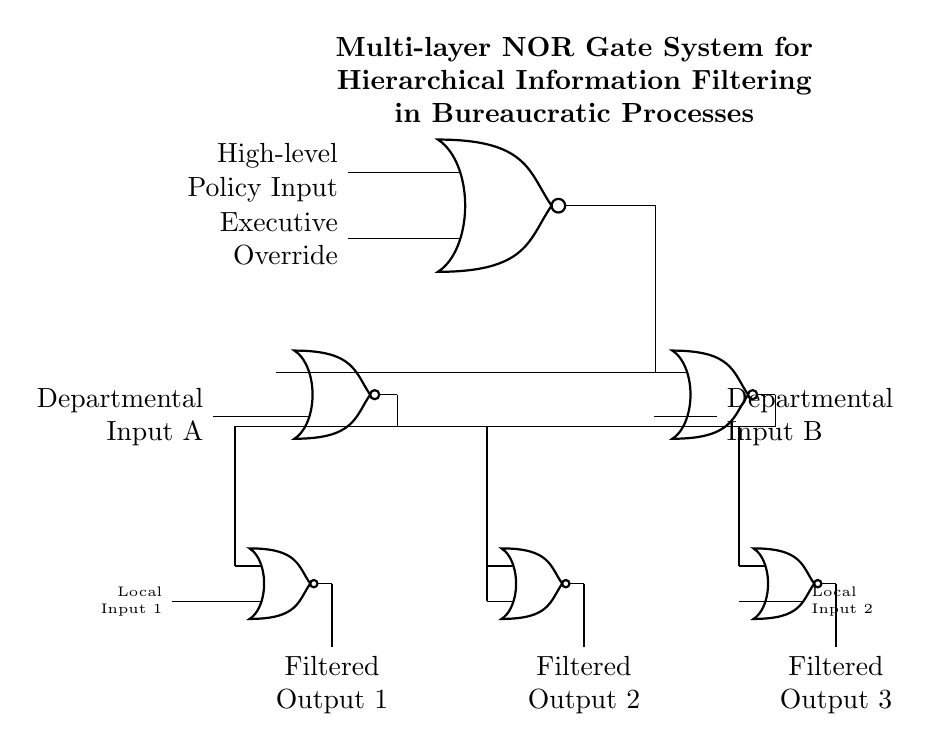What is the primary function of this circuit? The primary function of this circuit is to filter hierarchical information, specifically using NOR gates to process inputs at different levels of a bureaucracy.
Answer: Filtering hierarchical information How many layers of NOR gates are present in the circuit? The circuit contains three layers of NOR gates, with the top-most layer being the first level and the subsequent layers beneath it.
Answer: Three layers What are the inputs for the top-level NOR gate? The inputs for the top-level NOR gate are "High-level Policy Input" and "Executive Override." These inputs are fundamental for determining the output at the top level.
Answer: High-level Policy Input and Executive Override Which outputs are derived from the second layer of NOR gates? The outputs produced by the second layer NOR gates are "Filtered Output 1," "Filtered Output 2," and "Filtered Output 3." Each output corresponds to a distinct set of processed inputs from the layer above it.
Answer: Filtered Output 1, Filtered Output 2, Filtered Output 3 What type of logic gate is primarily used in this circuit? The type of logic gate used in this circuit is the NOR gate, which is a fundamental building block in digital electronics known for its complementary nature.
Answer: NOR gate How do the signals flow from the top layer to the third layer? The signals flow from the top-layer NOR gate to the second layer NOR gates through the outputs of the top gate, which are directly connected to the inputs of the second layer, creating a hierarchical structure of information processing.
Answer: Through direct connections 